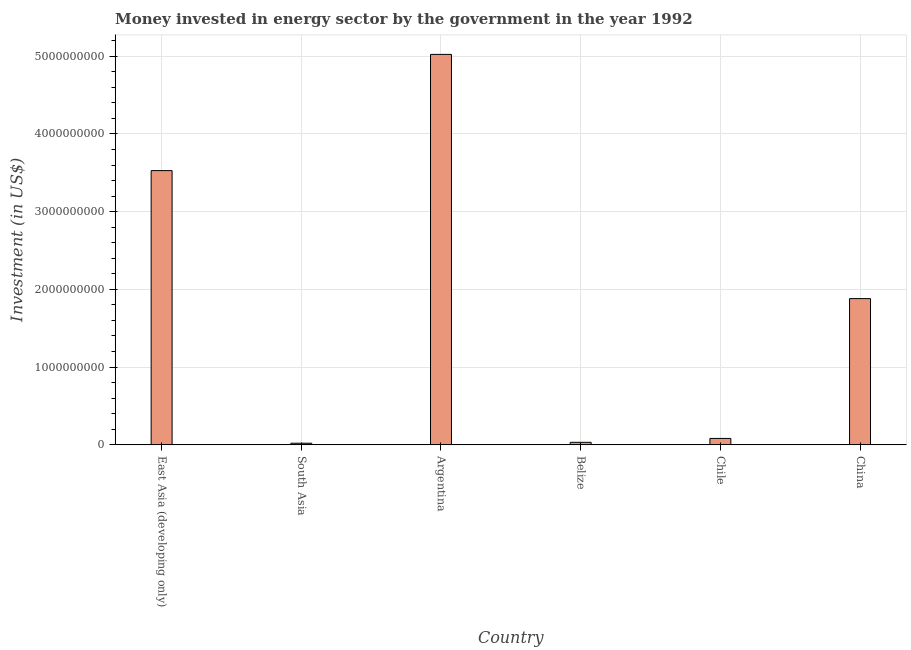Does the graph contain any zero values?
Offer a very short reply. No. What is the title of the graph?
Offer a very short reply. Money invested in energy sector by the government in the year 1992. What is the label or title of the Y-axis?
Provide a short and direct response. Investment (in US$). What is the investment in energy in South Asia?
Keep it short and to the point. 2.01e+07. Across all countries, what is the maximum investment in energy?
Give a very brief answer. 5.02e+09. Across all countries, what is the minimum investment in energy?
Keep it short and to the point. 2.01e+07. What is the sum of the investment in energy?
Provide a short and direct response. 1.06e+1. What is the difference between the investment in energy in Argentina and Chile?
Provide a short and direct response. 4.94e+09. What is the average investment in energy per country?
Offer a very short reply. 1.76e+09. What is the median investment in energy?
Offer a terse response. 9.82e+08. What is the ratio of the investment in energy in China to that in South Asia?
Your answer should be very brief. 93.58. Is the difference between the investment in energy in Belize and East Asia (developing only) greater than the difference between any two countries?
Offer a terse response. No. What is the difference between the highest and the second highest investment in energy?
Keep it short and to the point. 1.50e+09. Is the sum of the investment in energy in Argentina and East Asia (developing only) greater than the maximum investment in energy across all countries?
Your response must be concise. Yes. What is the difference between the highest and the lowest investment in energy?
Provide a short and direct response. 5.00e+09. In how many countries, is the investment in energy greater than the average investment in energy taken over all countries?
Offer a terse response. 3. Are all the bars in the graph horizontal?
Your response must be concise. No. What is the difference between two consecutive major ticks on the Y-axis?
Provide a short and direct response. 1.00e+09. What is the Investment (in US$) of East Asia (developing only)?
Keep it short and to the point. 3.53e+09. What is the Investment (in US$) in South Asia?
Offer a terse response. 2.01e+07. What is the Investment (in US$) of Argentina?
Make the answer very short. 5.02e+09. What is the Investment (in US$) in Belize?
Your answer should be compact. 3.19e+07. What is the Investment (in US$) of Chile?
Give a very brief answer. 8.20e+07. What is the Investment (in US$) in China?
Offer a very short reply. 1.88e+09. What is the difference between the Investment (in US$) in East Asia (developing only) and South Asia?
Offer a very short reply. 3.51e+09. What is the difference between the Investment (in US$) in East Asia (developing only) and Argentina?
Your answer should be very brief. -1.50e+09. What is the difference between the Investment (in US$) in East Asia (developing only) and Belize?
Ensure brevity in your answer.  3.50e+09. What is the difference between the Investment (in US$) in East Asia (developing only) and Chile?
Your answer should be compact. 3.45e+09. What is the difference between the Investment (in US$) in East Asia (developing only) and China?
Your answer should be compact. 1.65e+09. What is the difference between the Investment (in US$) in South Asia and Argentina?
Keep it short and to the point. -5.00e+09. What is the difference between the Investment (in US$) in South Asia and Belize?
Provide a short and direct response. -1.18e+07. What is the difference between the Investment (in US$) in South Asia and Chile?
Your response must be concise. -6.19e+07. What is the difference between the Investment (in US$) in South Asia and China?
Your response must be concise. -1.86e+09. What is the difference between the Investment (in US$) in Argentina and Belize?
Your response must be concise. 4.99e+09. What is the difference between the Investment (in US$) in Argentina and Chile?
Give a very brief answer. 4.94e+09. What is the difference between the Investment (in US$) in Argentina and China?
Ensure brevity in your answer.  3.14e+09. What is the difference between the Investment (in US$) in Belize and Chile?
Give a very brief answer. -5.01e+07. What is the difference between the Investment (in US$) in Belize and China?
Your answer should be compact. -1.85e+09. What is the difference between the Investment (in US$) in Chile and China?
Keep it short and to the point. -1.80e+09. What is the ratio of the Investment (in US$) in East Asia (developing only) to that in South Asia?
Ensure brevity in your answer.  175.52. What is the ratio of the Investment (in US$) in East Asia (developing only) to that in Argentina?
Ensure brevity in your answer.  0.7. What is the ratio of the Investment (in US$) in East Asia (developing only) to that in Belize?
Provide a short and direct response. 110.6. What is the ratio of the Investment (in US$) in East Asia (developing only) to that in Chile?
Your answer should be very brief. 43.02. What is the ratio of the Investment (in US$) in East Asia (developing only) to that in China?
Provide a short and direct response. 1.88. What is the ratio of the Investment (in US$) in South Asia to that in Argentina?
Provide a succinct answer. 0. What is the ratio of the Investment (in US$) in South Asia to that in Belize?
Your answer should be very brief. 0.63. What is the ratio of the Investment (in US$) in South Asia to that in Chile?
Offer a very short reply. 0.24. What is the ratio of the Investment (in US$) in South Asia to that in China?
Your answer should be very brief. 0.01. What is the ratio of the Investment (in US$) in Argentina to that in Belize?
Provide a succinct answer. 157.47. What is the ratio of the Investment (in US$) in Argentina to that in Chile?
Make the answer very short. 61.26. What is the ratio of the Investment (in US$) in Argentina to that in China?
Give a very brief answer. 2.67. What is the ratio of the Investment (in US$) in Belize to that in Chile?
Your answer should be compact. 0.39. What is the ratio of the Investment (in US$) in Belize to that in China?
Make the answer very short. 0.02. What is the ratio of the Investment (in US$) in Chile to that in China?
Ensure brevity in your answer.  0.04. 